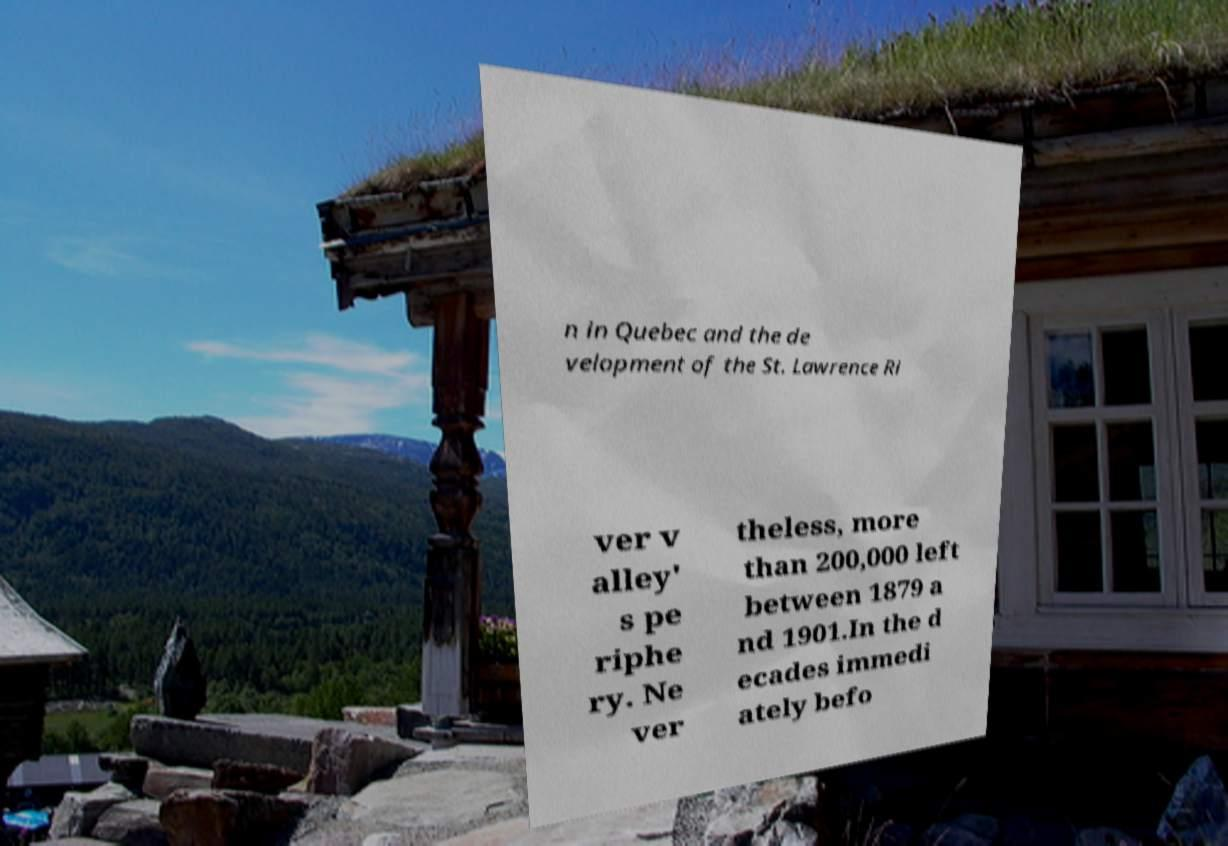Please identify and transcribe the text found in this image. n in Quebec and the de velopment of the St. Lawrence Ri ver v alley' s pe riphe ry. Ne ver theless, more than 200,000 left between 1879 a nd 1901.In the d ecades immedi ately befo 